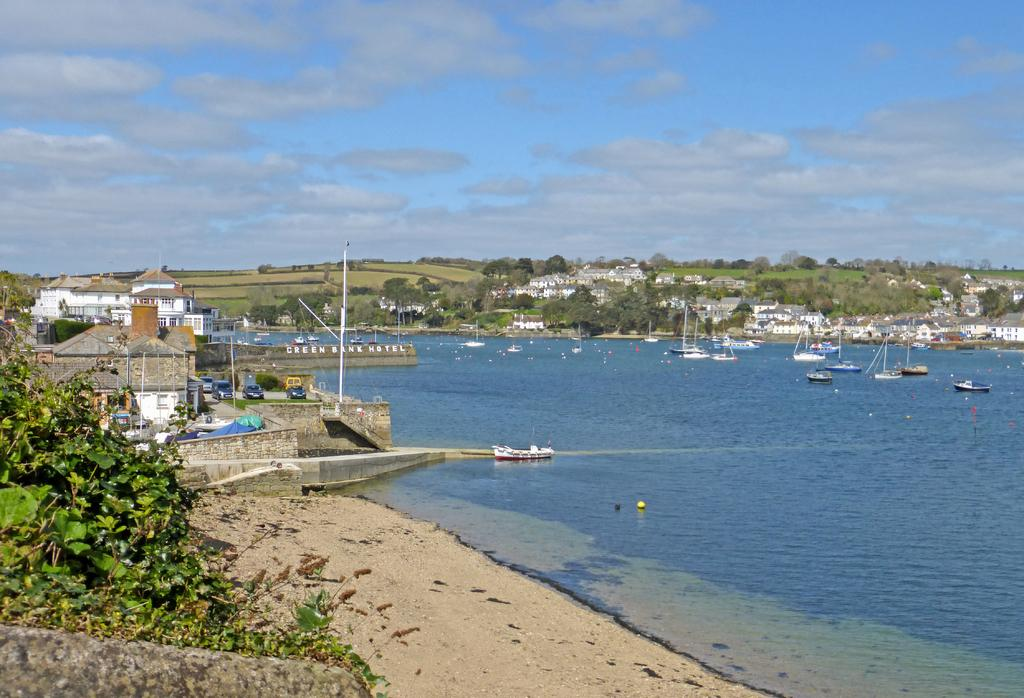What type of structures can be seen in the image? There are buildings in the image. What else is present in the image besides buildings? There are vehicles, poles, trees, plants, water, boats, grass, and the sky visible in the image. What is happening on the water in the image? Boats are sailing on the water. What type of natural environment can be seen in the image? There is grass and trees visible in the image. What is visible in the sky in the image? The sky is visible in the image, and clouds are present. How many men are playing in the organization in the image? There is no organization or men playing in the image; it features buildings, vehicles, poles, trees, plants, water, boats, grass, and the sky. 